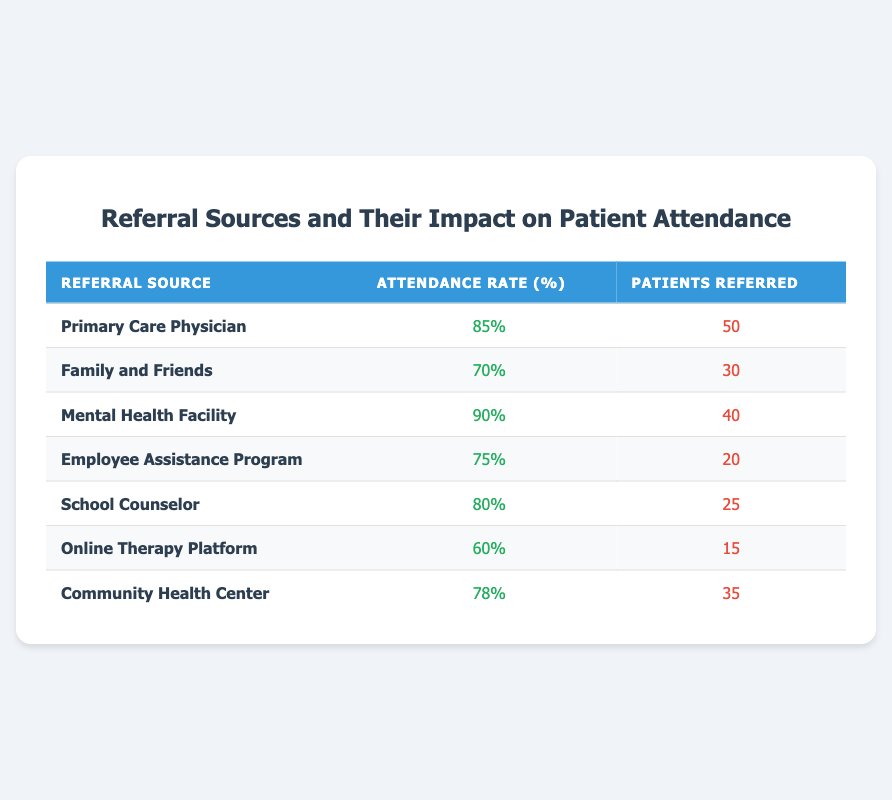What is the attendance rate for patients referred by the Mental Health Facility? The table shows that the attendance rate for patients referred by the Mental Health Facility is listed as 90%.
Answer: 90% How many patients were referred by the Employee Assistance Program? According to the table, the number of patients referred by the Employee Assistance Program is 20.
Answer: 20 What is the average attendance rate for all referral sources? To find the average attendance rate, add all the attendance rates: 85 + 70 + 90 + 75 + 80 + 60 + 78 =  538. Then divide by the number of sources (7), giving 538 / 7 = 76.86.
Answer: 76.86 Is the attendance rate for Family and Friends above 75%? The attendance rate for Family and Friends is 70%, which is not above 75%. Therefore, the answer is false.
Answer: No Which referral source has the highest attendance rate, and by how much does it exceed the second highest? The highest attendance rate is from the Mental Health Facility at 90%, and the second highest is from the Primary Care Physician at 85%. The difference is 90 - 85 = 5.
Answer: Mental Health Facility, 5 How many total patients were referred by all sources combined? To find the total patients referred, sum the patients referred from all sources: 50 + 30 + 40 + 20 + 25 + 15 + 35 = 215.
Answer: 215 Is the attendance rate for Online Therapy Platform lower than the community average of 78%? The attendance rate for the Online Therapy Platform is 60%, which is lower than the community average of 78%. Therefore, the answer is true.
Answer: Yes What is the attendance rate difference between the Primary Care Physician and the Community Health Center? The attendance rate for the Primary Care Physician is 85%, and for the Community Health Center, it is 78%. The difference is 85 - 78 = 7.
Answer: 7 